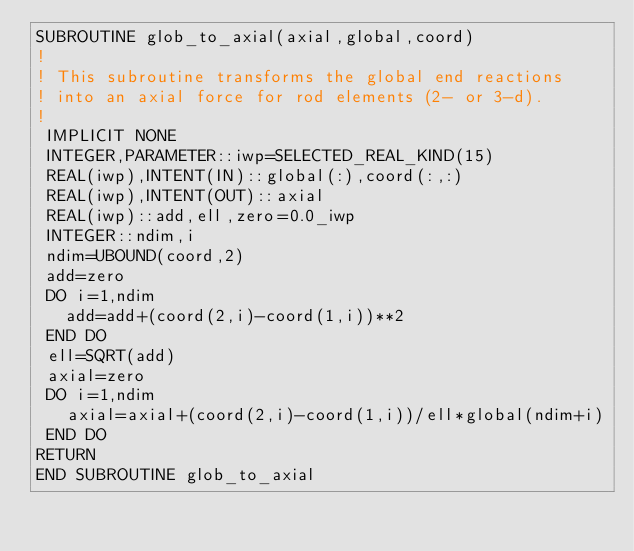Convert code to text. <code><loc_0><loc_0><loc_500><loc_500><_FORTRAN_>SUBROUTINE glob_to_axial(axial,global,coord)
!
! This subroutine transforms the global end reactions
! into an axial force for rod elements (2- or 3-d).
!
 IMPLICIT NONE
 INTEGER,PARAMETER::iwp=SELECTED_REAL_KIND(15)
 REAL(iwp),INTENT(IN)::global(:),coord(:,:)
 REAL(iwp),INTENT(OUT)::axial
 REAL(iwp)::add,ell,zero=0.0_iwp
 INTEGER::ndim,i
 ndim=UBOUND(coord,2)
 add=zero
 DO i=1,ndim
   add=add+(coord(2,i)-coord(1,i))**2
 END DO
 ell=SQRT(add)
 axial=zero
 DO i=1,ndim
   axial=axial+(coord(2,i)-coord(1,i))/ell*global(ndim+i)
 END DO
RETURN
END SUBROUTINE glob_to_axial                       
</code> 